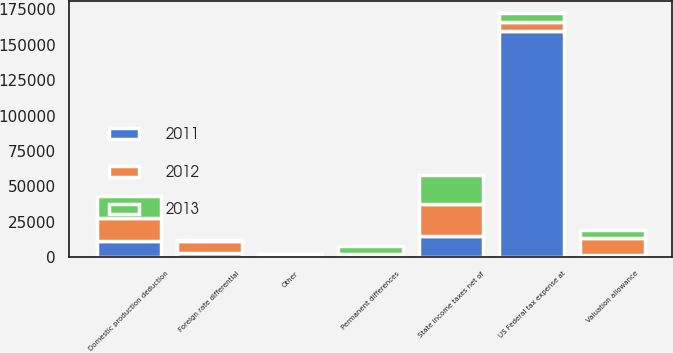<chart> <loc_0><loc_0><loc_500><loc_500><stacked_bar_chart><ecel><fcel>US Federal tax expense at<fcel>State income taxes net of<fcel>Permanent differences<fcel>Domestic production deduction<fcel>Other<fcel>Foreign rate differential<fcel>Valuation allowance<nl><fcel>2012<fcel>6142<fcel>22640<fcel>936<fcel>16039<fcel>266<fcel>8566<fcel>11501<nl><fcel>2013<fcel>6142<fcel>20252<fcel>5968<fcel>15469<fcel>388<fcel>425<fcel>6142<nl><fcel>2011<fcel>160045<fcel>14917<fcel>1176<fcel>11551<fcel>1538<fcel>3129<fcel>1797<nl></chart> 